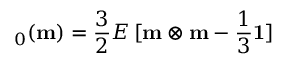<formula> <loc_0><loc_0><loc_500><loc_500>\varepsilon _ { 0 } ( m ) = { \frac { 3 } { 2 } } E \, [ m \otimes m - { \frac { 1 } { 3 } } 1 ]</formula> 